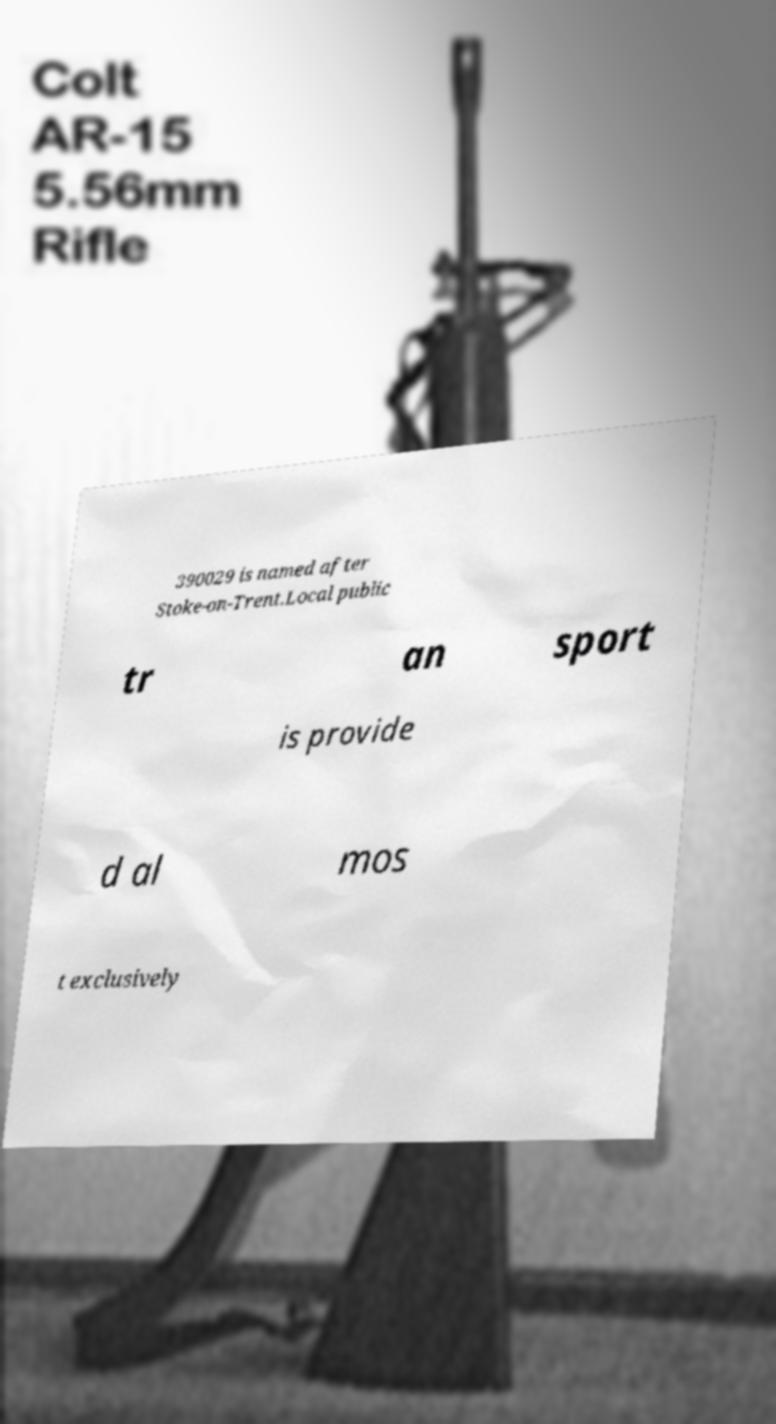Please identify and transcribe the text found in this image. 390029 is named after Stoke-on-Trent.Local public tr an sport is provide d al mos t exclusively 